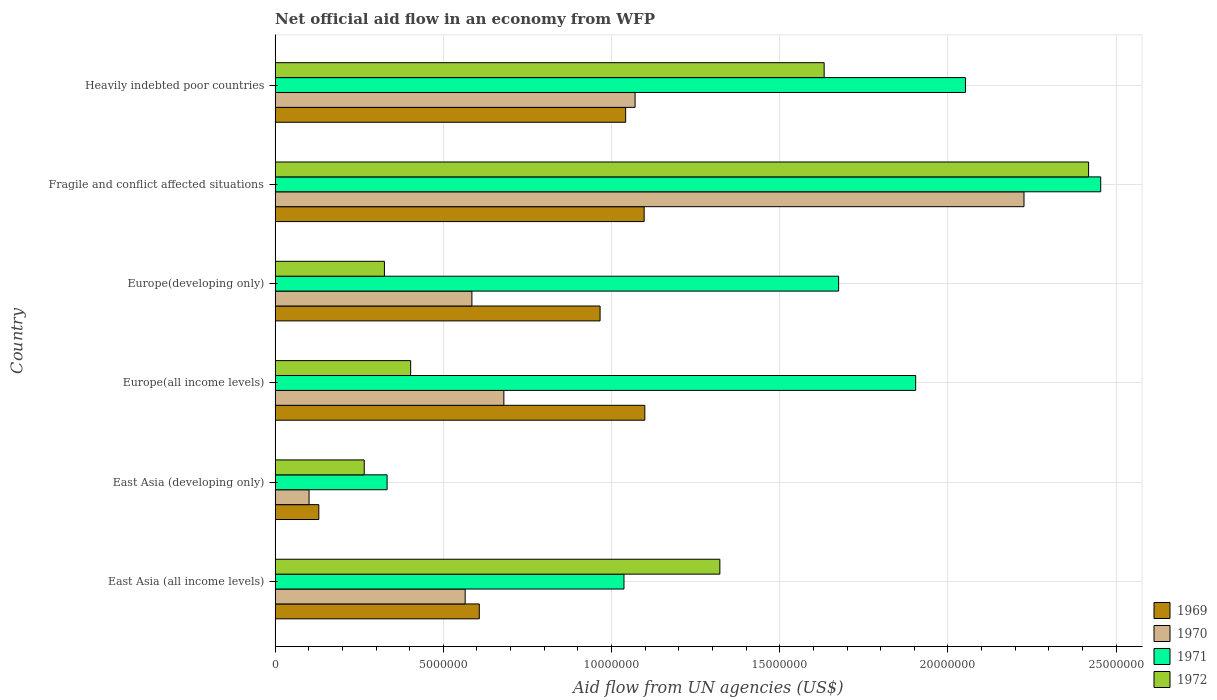Are the number of bars per tick equal to the number of legend labels?
Give a very brief answer. Yes. What is the label of the 5th group of bars from the top?
Your answer should be very brief. East Asia (developing only). In how many cases, is the number of bars for a given country not equal to the number of legend labels?
Offer a terse response. 0. What is the net official aid flow in 1970 in Europe(developing only)?
Ensure brevity in your answer.  5.85e+06. Across all countries, what is the maximum net official aid flow in 1972?
Offer a terse response. 2.42e+07. Across all countries, what is the minimum net official aid flow in 1970?
Ensure brevity in your answer.  1.01e+06. In which country was the net official aid flow in 1969 maximum?
Keep it short and to the point. Europe(all income levels). In which country was the net official aid flow in 1971 minimum?
Make the answer very short. East Asia (developing only). What is the total net official aid flow in 1969 in the graph?
Your answer should be very brief. 4.94e+07. What is the difference between the net official aid flow in 1970 in East Asia (all income levels) and that in East Asia (developing only)?
Provide a succinct answer. 4.64e+06. What is the difference between the net official aid flow in 1970 in East Asia (developing only) and the net official aid flow in 1969 in East Asia (all income levels)?
Provide a succinct answer. -5.06e+06. What is the average net official aid flow in 1969 per country?
Keep it short and to the point. 8.24e+06. What is the difference between the net official aid flow in 1971 and net official aid flow in 1970 in Europe(all income levels)?
Your answer should be very brief. 1.22e+07. What is the ratio of the net official aid flow in 1970 in East Asia (all income levels) to that in East Asia (developing only)?
Keep it short and to the point. 5.59. Is the net official aid flow in 1970 in Europe(all income levels) less than that in Europe(developing only)?
Provide a short and direct response. No. Is the difference between the net official aid flow in 1971 in East Asia (all income levels) and Heavily indebted poor countries greater than the difference between the net official aid flow in 1970 in East Asia (all income levels) and Heavily indebted poor countries?
Offer a terse response. No. What is the difference between the highest and the second highest net official aid flow in 1971?
Keep it short and to the point. 4.02e+06. What is the difference between the highest and the lowest net official aid flow in 1970?
Make the answer very short. 2.12e+07. What does the 1st bar from the top in Heavily indebted poor countries represents?
Make the answer very short. 1972. Is it the case that in every country, the sum of the net official aid flow in 1972 and net official aid flow in 1971 is greater than the net official aid flow in 1970?
Offer a very short reply. Yes. Are all the bars in the graph horizontal?
Ensure brevity in your answer.  Yes. What is the difference between two consecutive major ticks on the X-axis?
Keep it short and to the point. 5.00e+06. Are the values on the major ticks of X-axis written in scientific E-notation?
Offer a very short reply. No. Does the graph contain any zero values?
Keep it short and to the point. No. Does the graph contain grids?
Provide a succinct answer. Yes. Where does the legend appear in the graph?
Keep it short and to the point. Bottom right. How many legend labels are there?
Provide a succinct answer. 4. How are the legend labels stacked?
Your answer should be very brief. Vertical. What is the title of the graph?
Your answer should be compact. Net official aid flow in an economy from WFP. What is the label or title of the X-axis?
Keep it short and to the point. Aid flow from UN agencies (US$). What is the Aid flow from UN agencies (US$) in 1969 in East Asia (all income levels)?
Offer a terse response. 6.07e+06. What is the Aid flow from UN agencies (US$) in 1970 in East Asia (all income levels)?
Offer a very short reply. 5.65e+06. What is the Aid flow from UN agencies (US$) in 1971 in East Asia (all income levels)?
Offer a terse response. 1.04e+07. What is the Aid flow from UN agencies (US$) in 1972 in East Asia (all income levels)?
Provide a succinct answer. 1.32e+07. What is the Aid flow from UN agencies (US$) in 1969 in East Asia (developing only)?
Your answer should be very brief. 1.30e+06. What is the Aid flow from UN agencies (US$) in 1970 in East Asia (developing only)?
Offer a terse response. 1.01e+06. What is the Aid flow from UN agencies (US$) in 1971 in East Asia (developing only)?
Offer a very short reply. 3.33e+06. What is the Aid flow from UN agencies (US$) in 1972 in East Asia (developing only)?
Give a very brief answer. 2.65e+06. What is the Aid flow from UN agencies (US$) of 1969 in Europe(all income levels)?
Make the answer very short. 1.10e+07. What is the Aid flow from UN agencies (US$) of 1970 in Europe(all income levels)?
Ensure brevity in your answer.  6.80e+06. What is the Aid flow from UN agencies (US$) in 1971 in Europe(all income levels)?
Keep it short and to the point. 1.90e+07. What is the Aid flow from UN agencies (US$) in 1972 in Europe(all income levels)?
Offer a very short reply. 4.03e+06. What is the Aid flow from UN agencies (US$) in 1969 in Europe(developing only)?
Provide a succinct answer. 9.66e+06. What is the Aid flow from UN agencies (US$) of 1970 in Europe(developing only)?
Offer a very short reply. 5.85e+06. What is the Aid flow from UN agencies (US$) in 1971 in Europe(developing only)?
Ensure brevity in your answer.  1.68e+07. What is the Aid flow from UN agencies (US$) of 1972 in Europe(developing only)?
Provide a short and direct response. 3.25e+06. What is the Aid flow from UN agencies (US$) in 1969 in Fragile and conflict affected situations?
Make the answer very short. 1.10e+07. What is the Aid flow from UN agencies (US$) in 1970 in Fragile and conflict affected situations?
Make the answer very short. 2.23e+07. What is the Aid flow from UN agencies (US$) in 1971 in Fragile and conflict affected situations?
Your answer should be compact. 2.45e+07. What is the Aid flow from UN agencies (US$) in 1972 in Fragile and conflict affected situations?
Provide a succinct answer. 2.42e+07. What is the Aid flow from UN agencies (US$) in 1969 in Heavily indebted poor countries?
Keep it short and to the point. 1.04e+07. What is the Aid flow from UN agencies (US$) in 1970 in Heavily indebted poor countries?
Your response must be concise. 1.07e+07. What is the Aid flow from UN agencies (US$) in 1971 in Heavily indebted poor countries?
Your answer should be very brief. 2.05e+07. What is the Aid flow from UN agencies (US$) in 1972 in Heavily indebted poor countries?
Your response must be concise. 1.63e+07. Across all countries, what is the maximum Aid flow from UN agencies (US$) of 1969?
Your answer should be very brief. 1.10e+07. Across all countries, what is the maximum Aid flow from UN agencies (US$) in 1970?
Your answer should be very brief. 2.23e+07. Across all countries, what is the maximum Aid flow from UN agencies (US$) of 1971?
Provide a short and direct response. 2.45e+07. Across all countries, what is the maximum Aid flow from UN agencies (US$) in 1972?
Your response must be concise. 2.42e+07. Across all countries, what is the minimum Aid flow from UN agencies (US$) of 1969?
Provide a short and direct response. 1.30e+06. Across all countries, what is the minimum Aid flow from UN agencies (US$) of 1970?
Give a very brief answer. 1.01e+06. Across all countries, what is the minimum Aid flow from UN agencies (US$) in 1971?
Ensure brevity in your answer.  3.33e+06. Across all countries, what is the minimum Aid flow from UN agencies (US$) of 1972?
Your response must be concise. 2.65e+06. What is the total Aid flow from UN agencies (US$) of 1969 in the graph?
Offer a terse response. 4.94e+07. What is the total Aid flow from UN agencies (US$) of 1970 in the graph?
Give a very brief answer. 5.23e+07. What is the total Aid flow from UN agencies (US$) of 1971 in the graph?
Your response must be concise. 9.46e+07. What is the total Aid flow from UN agencies (US$) of 1972 in the graph?
Keep it short and to the point. 6.36e+07. What is the difference between the Aid flow from UN agencies (US$) of 1969 in East Asia (all income levels) and that in East Asia (developing only)?
Your answer should be compact. 4.77e+06. What is the difference between the Aid flow from UN agencies (US$) in 1970 in East Asia (all income levels) and that in East Asia (developing only)?
Give a very brief answer. 4.64e+06. What is the difference between the Aid flow from UN agencies (US$) of 1971 in East Asia (all income levels) and that in East Asia (developing only)?
Keep it short and to the point. 7.04e+06. What is the difference between the Aid flow from UN agencies (US$) of 1972 in East Asia (all income levels) and that in East Asia (developing only)?
Your answer should be very brief. 1.06e+07. What is the difference between the Aid flow from UN agencies (US$) of 1969 in East Asia (all income levels) and that in Europe(all income levels)?
Offer a terse response. -4.92e+06. What is the difference between the Aid flow from UN agencies (US$) of 1970 in East Asia (all income levels) and that in Europe(all income levels)?
Your answer should be very brief. -1.15e+06. What is the difference between the Aid flow from UN agencies (US$) of 1971 in East Asia (all income levels) and that in Europe(all income levels)?
Give a very brief answer. -8.67e+06. What is the difference between the Aid flow from UN agencies (US$) of 1972 in East Asia (all income levels) and that in Europe(all income levels)?
Your answer should be very brief. 9.19e+06. What is the difference between the Aid flow from UN agencies (US$) of 1969 in East Asia (all income levels) and that in Europe(developing only)?
Offer a very short reply. -3.59e+06. What is the difference between the Aid flow from UN agencies (US$) in 1970 in East Asia (all income levels) and that in Europe(developing only)?
Ensure brevity in your answer.  -2.00e+05. What is the difference between the Aid flow from UN agencies (US$) in 1971 in East Asia (all income levels) and that in Europe(developing only)?
Give a very brief answer. -6.38e+06. What is the difference between the Aid flow from UN agencies (US$) of 1972 in East Asia (all income levels) and that in Europe(developing only)?
Offer a terse response. 9.97e+06. What is the difference between the Aid flow from UN agencies (US$) in 1969 in East Asia (all income levels) and that in Fragile and conflict affected situations?
Offer a terse response. -4.90e+06. What is the difference between the Aid flow from UN agencies (US$) of 1970 in East Asia (all income levels) and that in Fragile and conflict affected situations?
Your answer should be very brief. -1.66e+07. What is the difference between the Aid flow from UN agencies (US$) of 1971 in East Asia (all income levels) and that in Fragile and conflict affected situations?
Make the answer very short. -1.42e+07. What is the difference between the Aid flow from UN agencies (US$) of 1972 in East Asia (all income levels) and that in Fragile and conflict affected situations?
Keep it short and to the point. -1.10e+07. What is the difference between the Aid flow from UN agencies (US$) in 1969 in East Asia (all income levels) and that in Heavily indebted poor countries?
Offer a very short reply. -4.35e+06. What is the difference between the Aid flow from UN agencies (US$) of 1970 in East Asia (all income levels) and that in Heavily indebted poor countries?
Make the answer very short. -5.05e+06. What is the difference between the Aid flow from UN agencies (US$) of 1971 in East Asia (all income levels) and that in Heavily indebted poor countries?
Keep it short and to the point. -1.02e+07. What is the difference between the Aid flow from UN agencies (US$) of 1972 in East Asia (all income levels) and that in Heavily indebted poor countries?
Offer a terse response. -3.10e+06. What is the difference between the Aid flow from UN agencies (US$) in 1969 in East Asia (developing only) and that in Europe(all income levels)?
Make the answer very short. -9.69e+06. What is the difference between the Aid flow from UN agencies (US$) in 1970 in East Asia (developing only) and that in Europe(all income levels)?
Offer a terse response. -5.79e+06. What is the difference between the Aid flow from UN agencies (US$) of 1971 in East Asia (developing only) and that in Europe(all income levels)?
Provide a succinct answer. -1.57e+07. What is the difference between the Aid flow from UN agencies (US$) of 1972 in East Asia (developing only) and that in Europe(all income levels)?
Your answer should be compact. -1.38e+06. What is the difference between the Aid flow from UN agencies (US$) in 1969 in East Asia (developing only) and that in Europe(developing only)?
Your answer should be very brief. -8.36e+06. What is the difference between the Aid flow from UN agencies (US$) of 1970 in East Asia (developing only) and that in Europe(developing only)?
Provide a short and direct response. -4.84e+06. What is the difference between the Aid flow from UN agencies (US$) of 1971 in East Asia (developing only) and that in Europe(developing only)?
Offer a very short reply. -1.34e+07. What is the difference between the Aid flow from UN agencies (US$) in 1972 in East Asia (developing only) and that in Europe(developing only)?
Keep it short and to the point. -6.00e+05. What is the difference between the Aid flow from UN agencies (US$) of 1969 in East Asia (developing only) and that in Fragile and conflict affected situations?
Your answer should be very brief. -9.67e+06. What is the difference between the Aid flow from UN agencies (US$) of 1970 in East Asia (developing only) and that in Fragile and conflict affected situations?
Give a very brief answer. -2.12e+07. What is the difference between the Aid flow from UN agencies (US$) of 1971 in East Asia (developing only) and that in Fragile and conflict affected situations?
Ensure brevity in your answer.  -2.12e+07. What is the difference between the Aid flow from UN agencies (US$) of 1972 in East Asia (developing only) and that in Fragile and conflict affected situations?
Keep it short and to the point. -2.15e+07. What is the difference between the Aid flow from UN agencies (US$) in 1969 in East Asia (developing only) and that in Heavily indebted poor countries?
Your answer should be very brief. -9.12e+06. What is the difference between the Aid flow from UN agencies (US$) of 1970 in East Asia (developing only) and that in Heavily indebted poor countries?
Ensure brevity in your answer.  -9.69e+06. What is the difference between the Aid flow from UN agencies (US$) of 1971 in East Asia (developing only) and that in Heavily indebted poor countries?
Offer a very short reply. -1.72e+07. What is the difference between the Aid flow from UN agencies (US$) of 1972 in East Asia (developing only) and that in Heavily indebted poor countries?
Your response must be concise. -1.37e+07. What is the difference between the Aid flow from UN agencies (US$) of 1969 in Europe(all income levels) and that in Europe(developing only)?
Offer a very short reply. 1.33e+06. What is the difference between the Aid flow from UN agencies (US$) in 1970 in Europe(all income levels) and that in Europe(developing only)?
Provide a succinct answer. 9.50e+05. What is the difference between the Aid flow from UN agencies (US$) of 1971 in Europe(all income levels) and that in Europe(developing only)?
Your response must be concise. 2.29e+06. What is the difference between the Aid flow from UN agencies (US$) of 1972 in Europe(all income levels) and that in Europe(developing only)?
Make the answer very short. 7.80e+05. What is the difference between the Aid flow from UN agencies (US$) of 1969 in Europe(all income levels) and that in Fragile and conflict affected situations?
Keep it short and to the point. 2.00e+04. What is the difference between the Aid flow from UN agencies (US$) of 1970 in Europe(all income levels) and that in Fragile and conflict affected situations?
Ensure brevity in your answer.  -1.55e+07. What is the difference between the Aid flow from UN agencies (US$) of 1971 in Europe(all income levels) and that in Fragile and conflict affected situations?
Give a very brief answer. -5.50e+06. What is the difference between the Aid flow from UN agencies (US$) of 1972 in Europe(all income levels) and that in Fragile and conflict affected situations?
Your answer should be compact. -2.02e+07. What is the difference between the Aid flow from UN agencies (US$) in 1969 in Europe(all income levels) and that in Heavily indebted poor countries?
Offer a terse response. 5.70e+05. What is the difference between the Aid flow from UN agencies (US$) of 1970 in Europe(all income levels) and that in Heavily indebted poor countries?
Give a very brief answer. -3.90e+06. What is the difference between the Aid flow from UN agencies (US$) of 1971 in Europe(all income levels) and that in Heavily indebted poor countries?
Keep it short and to the point. -1.48e+06. What is the difference between the Aid flow from UN agencies (US$) of 1972 in Europe(all income levels) and that in Heavily indebted poor countries?
Offer a terse response. -1.23e+07. What is the difference between the Aid flow from UN agencies (US$) in 1969 in Europe(developing only) and that in Fragile and conflict affected situations?
Offer a very short reply. -1.31e+06. What is the difference between the Aid flow from UN agencies (US$) in 1970 in Europe(developing only) and that in Fragile and conflict affected situations?
Give a very brief answer. -1.64e+07. What is the difference between the Aid flow from UN agencies (US$) of 1971 in Europe(developing only) and that in Fragile and conflict affected situations?
Your answer should be compact. -7.79e+06. What is the difference between the Aid flow from UN agencies (US$) in 1972 in Europe(developing only) and that in Fragile and conflict affected situations?
Your answer should be very brief. -2.09e+07. What is the difference between the Aid flow from UN agencies (US$) of 1969 in Europe(developing only) and that in Heavily indebted poor countries?
Offer a terse response. -7.60e+05. What is the difference between the Aid flow from UN agencies (US$) in 1970 in Europe(developing only) and that in Heavily indebted poor countries?
Provide a succinct answer. -4.85e+06. What is the difference between the Aid flow from UN agencies (US$) in 1971 in Europe(developing only) and that in Heavily indebted poor countries?
Offer a terse response. -3.77e+06. What is the difference between the Aid flow from UN agencies (US$) of 1972 in Europe(developing only) and that in Heavily indebted poor countries?
Give a very brief answer. -1.31e+07. What is the difference between the Aid flow from UN agencies (US$) of 1970 in Fragile and conflict affected situations and that in Heavily indebted poor countries?
Keep it short and to the point. 1.16e+07. What is the difference between the Aid flow from UN agencies (US$) of 1971 in Fragile and conflict affected situations and that in Heavily indebted poor countries?
Give a very brief answer. 4.02e+06. What is the difference between the Aid flow from UN agencies (US$) of 1972 in Fragile and conflict affected situations and that in Heavily indebted poor countries?
Make the answer very short. 7.86e+06. What is the difference between the Aid flow from UN agencies (US$) in 1969 in East Asia (all income levels) and the Aid flow from UN agencies (US$) in 1970 in East Asia (developing only)?
Give a very brief answer. 5.06e+06. What is the difference between the Aid flow from UN agencies (US$) of 1969 in East Asia (all income levels) and the Aid flow from UN agencies (US$) of 1971 in East Asia (developing only)?
Your response must be concise. 2.74e+06. What is the difference between the Aid flow from UN agencies (US$) of 1969 in East Asia (all income levels) and the Aid flow from UN agencies (US$) of 1972 in East Asia (developing only)?
Provide a short and direct response. 3.42e+06. What is the difference between the Aid flow from UN agencies (US$) of 1970 in East Asia (all income levels) and the Aid flow from UN agencies (US$) of 1971 in East Asia (developing only)?
Provide a short and direct response. 2.32e+06. What is the difference between the Aid flow from UN agencies (US$) of 1970 in East Asia (all income levels) and the Aid flow from UN agencies (US$) of 1972 in East Asia (developing only)?
Keep it short and to the point. 3.00e+06. What is the difference between the Aid flow from UN agencies (US$) of 1971 in East Asia (all income levels) and the Aid flow from UN agencies (US$) of 1972 in East Asia (developing only)?
Your response must be concise. 7.72e+06. What is the difference between the Aid flow from UN agencies (US$) of 1969 in East Asia (all income levels) and the Aid flow from UN agencies (US$) of 1970 in Europe(all income levels)?
Give a very brief answer. -7.30e+05. What is the difference between the Aid flow from UN agencies (US$) of 1969 in East Asia (all income levels) and the Aid flow from UN agencies (US$) of 1971 in Europe(all income levels)?
Your response must be concise. -1.30e+07. What is the difference between the Aid flow from UN agencies (US$) of 1969 in East Asia (all income levels) and the Aid flow from UN agencies (US$) of 1972 in Europe(all income levels)?
Your response must be concise. 2.04e+06. What is the difference between the Aid flow from UN agencies (US$) of 1970 in East Asia (all income levels) and the Aid flow from UN agencies (US$) of 1971 in Europe(all income levels)?
Your answer should be compact. -1.34e+07. What is the difference between the Aid flow from UN agencies (US$) of 1970 in East Asia (all income levels) and the Aid flow from UN agencies (US$) of 1972 in Europe(all income levels)?
Give a very brief answer. 1.62e+06. What is the difference between the Aid flow from UN agencies (US$) of 1971 in East Asia (all income levels) and the Aid flow from UN agencies (US$) of 1972 in Europe(all income levels)?
Provide a succinct answer. 6.34e+06. What is the difference between the Aid flow from UN agencies (US$) in 1969 in East Asia (all income levels) and the Aid flow from UN agencies (US$) in 1971 in Europe(developing only)?
Provide a succinct answer. -1.07e+07. What is the difference between the Aid flow from UN agencies (US$) in 1969 in East Asia (all income levels) and the Aid flow from UN agencies (US$) in 1972 in Europe(developing only)?
Offer a terse response. 2.82e+06. What is the difference between the Aid flow from UN agencies (US$) of 1970 in East Asia (all income levels) and the Aid flow from UN agencies (US$) of 1971 in Europe(developing only)?
Make the answer very short. -1.11e+07. What is the difference between the Aid flow from UN agencies (US$) in 1970 in East Asia (all income levels) and the Aid flow from UN agencies (US$) in 1972 in Europe(developing only)?
Ensure brevity in your answer.  2.40e+06. What is the difference between the Aid flow from UN agencies (US$) of 1971 in East Asia (all income levels) and the Aid flow from UN agencies (US$) of 1972 in Europe(developing only)?
Your response must be concise. 7.12e+06. What is the difference between the Aid flow from UN agencies (US$) in 1969 in East Asia (all income levels) and the Aid flow from UN agencies (US$) in 1970 in Fragile and conflict affected situations?
Offer a very short reply. -1.62e+07. What is the difference between the Aid flow from UN agencies (US$) in 1969 in East Asia (all income levels) and the Aid flow from UN agencies (US$) in 1971 in Fragile and conflict affected situations?
Offer a very short reply. -1.85e+07. What is the difference between the Aid flow from UN agencies (US$) in 1969 in East Asia (all income levels) and the Aid flow from UN agencies (US$) in 1972 in Fragile and conflict affected situations?
Make the answer very short. -1.81e+07. What is the difference between the Aid flow from UN agencies (US$) of 1970 in East Asia (all income levels) and the Aid flow from UN agencies (US$) of 1971 in Fragile and conflict affected situations?
Give a very brief answer. -1.89e+07. What is the difference between the Aid flow from UN agencies (US$) of 1970 in East Asia (all income levels) and the Aid flow from UN agencies (US$) of 1972 in Fragile and conflict affected situations?
Your answer should be very brief. -1.85e+07. What is the difference between the Aid flow from UN agencies (US$) in 1971 in East Asia (all income levels) and the Aid flow from UN agencies (US$) in 1972 in Fragile and conflict affected situations?
Provide a short and direct response. -1.38e+07. What is the difference between the Aid flow from UN agencies (US$) of 1969 in East Asia (all income levels) and the Aid flow from UN agencies (US$) of 1970 in Heavily indebted poor countries?
Give a very brief answer. -4.63e+06. What is the difference between the Aid flow from UN agencies (US$) of 1969 in East Asia (all income levels) and the Aid flow from UN agencies (US$) of 1971 in Heavily indebted poor countries?
Provide a short and direct response. -1.44e+07. What is the difference between the Aid flow from UN agencies (US$) in 1969 in East Asia (all income levels) and the Aid flow from UN agencies (US$) in 1972 in Heavily indebted poor countries?
Ensure brevity in your answer.  -1.02e+07. What is the difference between the Aid flow from UN agencies (US$) in 1970 in East Asia (all income levels) and the Aid flow from UN agencies (US$) in 1971 in Heavily indebted poor countries?
Keep it short and to the point. -1.49e+07. What is the difference between the Aid flow from UN agencies (US$) in 1970 in East Asia (all income levels) and the Aid flow from UN agencies (US$) in 1972 in Heavily indebted poor countries?
Your answer should be compact. -1.07e+07. What is the difference between the Aid flow from UN agencies (US$) in 1971 in East Asia (all income levels) and the Aid flow from UN agencies (US$) in 1972 in Heavily indebted poor countries?
Give a very brief answer. -5.95e+06. What is the difference between the Aid flow from UN agencies (US$) in 1969 in East Asia (developing only) and the Aid flow from UN agencies (US$) in 1970 in Europe(all income levels)?
Offer a very short reply. -5.50e+06. What is the difference between the Aid flow from UN agencies (US$) in 1969 in East Asia (developing only) and the Aid flow from UN agencies (US$) in 1971 in Europe(all income levels)?
Offer a terse response. -1.77e+07. What is the difference between the Aid flow from UN agencies (US$) in 1969 in East Asia (developing only) and the Aid flow from UN agencies (US$) in 1972 in Europe(all income levels)?
Make the answer very short. -2.73e+06. What is the difference between the Aid flow from UN agencies (US$) of 1970 in East Asia (developing only) and the Aid flow from UN agencies (US$) of 1971 in Europe(all income levels)?
Your answer should be compact. -1.80e+07. What is the difference between the Aid flow from UN agencies (US$) of 1970 in East Asia (developing only) and the Aid flow from UN agencies (US$) of 1972 in Europe(all income levels)?
Ensure brevity in your answer.  -3.02e+06. What is the difference between the Aid flow from UN agencies (US$) of 1971 in East Asia (developing only) and the Aid flow from UN agencies (US$) of 1972 in Europe(all income levels)?
Ensure brevity in your answer.  -7.00e+05. What is the difference between the Aid flow from UN agencies (US$) of 1969 in East Asia (developing only) and the Aid flow from UN agencies (US$) of 1970 in Europe(developing only)?
Your answer should be very brief. -4.55e+06. What is the difference between the Aid flow from UN agencies (US$) in 1969 in East Asia (developing only) and the Aid flow from UN agencies (US$) in 1971 in Europe(developing only)?
Provide a short and direct response. -1.54e+07. What is the difference between the Aid flow from UN agencies (US$) in 1969 in East Asia (developing only) and the Aid flow from UN agencies (US$) in 1972 in Europe(developing only)?
Provide a short and direct response. -1.95e+06. What is the difference between the Aid flow from UN agencies (US$) in 1970 in East Asia (developing only) and the Aid flow from UN agencies (US$) in 1971 in Europe(developing only)?
Give a very brief answer. -1.57e+07. What is the difference between the Aid flow from UN agencies (US$) in 1970 in East Asia (developing only) and the Aid flow from UN agencies (US$) in 1972 in Europe(developing only)?
Ensure brevity in your answer.  -2.24e+06. What is the difference between the Aid flow from UN agencies (US$) of 1971 in East Asia (developing only) and the Aid flow from UN agencies (US$) of 1972 in Europe(developing only)?
Give a very brief answer. 8.00e+04. What is the difference between the Aid flow from UN agencies (US$) of 1969 in East Asia (developing only) and the Aid flow from UN agencies (US$) of 1970 in Fragile and conflict affected situations?
Provide a short and direct response. -2.10e+07. What is the difference between the Aid flow from UN agencies (US$) of 1969 in East Asia (developing only) and the Aid flow from UN agencies (US$) of 1971 in Fragile and conflict affected situations?
Your answer should be compact. -2.32e+07. What is the difference between the Aid flow from UN agencies (US$) in 1969 in East Asia (developing only) and the Aid flow from UN agencies (US$) in 1972 in Fragile and conflict affected situations?
Provide a short and direct response. -2.29e+07. What is the difference between the Aid flow from UN agencies (US$) in 1970 in East Asia (developing only) and the Aid flow from UN agencies (US$) in 1971 in Fragile and conflict affected situations?
Provide a short and direct response. -2.35e+07. What is the difference between the Aid flow from UN agencies (US$) of 1970 in East Asia (developing only) and the Aid flow from UN agencies (US$) of 1972 in Fragile and conflict affected situations?
Offer a terse response. -2.32e+07. What is the difference between the Aid flow from UN agencies (US$) in 1971 in East Asia (developing only) and the Aid flow from UN agencies (US$) in 1972 in Fragile and conflict affected situations?
Your response must be concise. -2.08e+07. What is the difference between the Aid flow from UN agencies (US$) in 1969 in East Asia (developing only) and the Aid flow from UN agencies (US$) in 1970 in Heavily indebted poor countries?
Provide a succinct answer. -9.40e+06. What is the difference between the Aid flow from UN agencies (US$) in 1969 in East Asia (developing only) and the Aid flow from UN agencies (US$) in 1971 in Heavily indebted poor countries?
Your answer should be very brief. -1.92e+07. What is the difference between the Aid flow from UN agencies (US$) of 1969 in East Asia (developing only) and the Aid flow from UN agencies (US$) of 1972 in Heavily indebted poor countries?
Provide a short and direct response. -1.50e+07. What is the difference between the Aid flow from UN agencies (US$) in 1970 in East Asia (developing only) and the Aid flow from UN agencies (US$) in 1971 in Heavily indebted poor countries?
Make the answer very short. -1.95e+07. What is the difference between the Aid flow from UN agencies (US$) in 1970 in East Asia (developing only) and the Aid flow from UN agencies (US$) in 1972 in Heavily indebted poor countries?
Your answer should be very brief. -1.53e+07. What is the difference between the Aid flow from UN agencies (US$) in 1971 in East Asia (developing only) and the Aid flow from UN agencies (US$) in 1972 in Heavily indebted poor countries?
Keep it short and to the point. -1.30e+07. What is the difference between the Aid flow from UN agencies (US$) in 1969 in Europe(all income levels) and the Aid flow from UN agencies (US$) in 1970 in Europe(developing only)?
Ensure brevity in your answer.  5.14e+06. What is the difference between the Aid flow from UN agencies (US$) in 1969 in Europe(all income levels) and the Aid flow from UN agencies (US$) in 1971 in Europe(developing only)?
Provide a short and direct response. -5.76e+06. What is the difference between the Aid flow from UN agencies (US$) of 1969 in Europe(all income levels) and the Aid flow from UN agencies (US$) of 1972 in Europe(developing only)?
Offer a very short reply. 7.74e+06. What is the difference between the Aid flow from UN agencies (US$) of 1970 in Europe(all income levels) and the Aid flow from UN agencies (US$) of 1971 in Europe(developing only)?
Make the answer very short. -9.95e+06. What is the difference between the Aid flow from UN agencies (US$) in 1970 in Europe(all income levels) and the Aid flow from UN agencies (US$) in 1972 in Europe(developing only)?
Give a very brief answer. 3.55e+06. What is the difference between the Aid flow from UN agencies (US$) of 1971 in Europe(all income levels) and the Aid flow from UN agencies (US$) of 1972 in Europe(developing only)?
Offer a terse response. 1.58e+07. What is the difference between the Aid flow from UN agencies (US$) of 1969 in Europe(all income levels) and the Aid flow from UN agencies (US$) of 1970 in Fragile and conflict affected situations?
Offer a very short reply. -1.13e+07. What is the difference between the Aid flow from UN agencies (US$) of 1969 in Europe(all income levels) and the Aid flow from UN agencies (US$) of 1971 in Fragile and conflict affected situations?
Offer a terse response. -1.36e+07. What is the difference between the Aid flow from UN agencies (US$) of 1969 in Europe(all income levels) and the Aid flow from UN agencies (US$) of 1972 in Fragile and conflict affected situations?
Give a very brief answer. -1.32e+07. What is the difference between the Aid flow from UN agencies (US$) of 1970 in Europe(all income levels) and the Aid flow from UN agencies (US$) of 1971 in Fragile and conflict affected situations?
Ensure brevity in your answer.  -1.77e+07. What is the difference between the Aid flow from UN agencies (US$) of 1970 in Europe(all income levels) and the Aid flow from UN agencies (US$) of 1972 in Fragile and conflict affected situations?
Offer a very short reply. -1.74e+07. What is the difference between the Aid flow from UN agencies (US$) in 1971 in Europe(all income levels) and the Aid flow from UN agencies (US$) in 1972 in Fragile and conflict affected situations?
Make the answer very short. -5.14e+06. What is the difference between the Aid flow from UN agencies (US$) of 1969 in Europe(all income levels) and the Aid flow from UN agencies (US$) of 1970 in Heavily indebted poor countries?
Make the answer very short. 2.90e+05. What is the difference between the Aid flow from UN agencies (US$) of 1969 in Europe(all income levels) and the Aid flow from UN agencies (US$) of 1971 in Heavily indebted poor countries?
Provide a succinct answer. -9.53e+06. What is the difference between the Aid flow from UN agencies (US$) of 1969 in Europe(all income levels) and the Aid flow from UN agencies (US$) of 1972 in Heavily indebted poor countries?
Ensure brevity in your answer.  -5.33e+06. What is the difference between the Aid flow from UN agencies (US$) in 1970 in Europe(all income levels) and the Aid flow from UN agencies (US$) in 1971 in Heavily indebted poor countries?
Your answer should be compact. -1.37e+07. What is the difference between the Aid flow from UN agencies (US$) of 1970 in Europe(all income levels) and the Aid flow from UN agencies (US$) of 1972 in Heavily indebted poor countries?
Keep it short and to the point. -9.52e+06. What is the difference between the Aid flow from UN agencies (US$) in 1971 in Europe(all income levels) and the Aid flow from UN agencies (US$) in 1972 in Heavily indebted poor countries?
Ensure brevity in your answer.  2.72e+06. What is the difference between the Aid flow from UN agencies (US$) of 1969 in Europe(developing only) and the Aid flow from UN agencies (US$) of 1970 in Fragile and conflict affected situations?
Offer a terse response. -1.26e+07. What is the difference between the Aid flow from UN agencies (US$) in 1969 in Europe(developing only) and the Aid flow from UN agencies (US$) in 1971 in Fragile and conflict affected situations?
Keep it short and to the point. -1.49e+07. What is the difference between the Aid flow from UN agencies (US$) in 1969 in Europe(developing only) and the Aid flow from UN agencies (US$) in 1972 in Fragile and conflict affected situations?
Ensure brevity in your answer.  -1.45e+07. What is the difference between the Aid flow from UN agencies (US$) in 1970 in Europe(developing only) and the Aid flow from UN agencies (US$) in 1971 in Fragile and conflict affected situations?
Keep it short and to the point. -1.87e+07. What is the difference between the Aid flow from UN agencies (US$) of 1970 in Europe(developing only) and the Aid flow from UN agencies (US$) of 1972 in Fragile and conflict affected situations?
Ensure brevity in your answer.  -1.83e+07. What is the difference between the Aid flow from UN agencies (US$) in 1971 in Europe(developing only) and the Aid flow from UN agencies (US$) in 1972 in Fragile and conflict affected situations?
Offer a very short reply. -7.43e+06. What is the difference between the Aid flow from UN agencies (US$) in 1969 in Europe(developing only) and the Aid flow from UN agencies (US$) in 1970 in Heavily indebted poor countries?
Your response must be concise. -1.04e+06. What is the difference between the Aid flow from UN agencies (US$) in 1969 in Europe(developing only) and the Aid flow from UN agencies (US$) in 1971 in Heavily indebted poor countries?
Your answer should be very brief. -1.09e+07. What is the difference between the Aid flow from UN agencies (US$) of 1969 in Europe(developing only) and the Aid flow from UN agencies (US$) of 1972 in Heavily indebted poor countries?
Offer a terse response. -6.66e+06. What is the difference between the Aid flow from UN agencies (US$) in 1970 in Europe(developing only) and the Aid flow from UN agencies (US$) in 1971 in Heavily indebted poor countries?
Provide a short and direct response. -1.47e+07. What is the difference between the Aid flow from UN agencies (US$) in 1970 in Europe(developing only) and the Aid flow from UN agencies (US$) in 1972 in Heavily indebted poor countries?
Provide a succinct answer. -1.05e+07. What is the difference between the Aid flow from UN agencies (US$) of 1971 in Europe(developing only) and the Aid flow from UN agencies (US$) of 1972 in Heavily indebted poor countries?
Ensure brevity in your answer.  4.30e+05. What is the difference between the Aid flow from UN agencies (US$) in 1969 in Fragile and conflict affected situations and the Aid flow from UN agencies (US$) in 1970 in Heavily indebted poor countries?
Your answer should be compact. 2.70e+05. What is the difference between the Aid flow from UN agencies (US$) of 1969 in Fragile and conflict affected situations and the Aid flow from UN agencies (US$) of 1971 in Heavily indebted poor countries?
Your answer should be very brief. -9.55e+06. What is the difference between the Aid flow from UN agencies (US$) of 1969 in Fragile and conflict affected situations and the Aid flow from UN agencies (US$) of 1972 in Heavily indebted poor countries?
Make the answer very short. -5.35e+06. What is the difference between the Aid flow from UN agencies (US$) in 1970 in Fragile and conflict affected situations and the Aid flow from UN agencies (US$) in 1971 in Heavily indebted poor countries?
Provide a succinct answer. 1.74e+06. What is the difference between the Aid flow from UN agencies (US$) in 1970 in Fragile and conflict affected situations and the Aid flow from UN agencies (US$) in 1972 in Heavily indebted poor countries?
Provide a succinct answer. 5.94e+06. What is the difference between the Aid flow from UN agencies (US$) of 1971 in Fragile and conflict affected situations and the Aid flow from UN agencies (US$) of 1972 in Heavily indebted poor countries?
Offer a terse response. 8.22e+06. What is the average Aid flow from UN agencies (US$) of 1969 per country?
Keep it short and to the point. 8.24e+06. What is the average Aid flow from UN agencies (US$) in 1970 per country?
Provide a succinct answer. 8.71e+06. What is the average Aid flow from UN agencies (US$) of 1971 per country?
Make the answer very short. 1.58e+07. What is the average Aid flow from UN agencies (US$) of 1972 per country?
Ensure brevity in your answer.  1.06e+07. What is the difference between the Aid flow from UN agencies (US$) of 1969 and Aid flow from UN agencies (US$) of 1971 in East Asia (all income levels)?
Make the answer very short. -4.30e+06. What is the difference between the Aid flow from UN agencies (US$) in 1969 and Aid flow from UN agencies (US$) in 1972 in East Asia (all income levels)?
Your response must be concise. -7.15e+06. What is the difference between the Aid flow from UN agencies (US$) of 1970 and Aid flow from UN agencies (US$) of 1971 in East Asia (all income levels)?
Your answer should be very brief. -4.72e+06. What is the difference between the Aid flow from UN agencies (US$) of 1970 and Aid flow from UN agencies (US$) of 1972 in East Asia (all income levels)?
Provide a succinct answer. -7.57e+06. What is the difference between the Aid flow from UN agencies (US$) of 1971 and Aid flow from UN agencies (US$) of 1972 in East Asia (all income levels)?
Your answer should be compact. -2.85e+06. What is the difference between the Aid flow from UN agencies (US$) of 1969 and Aid flow from UN agencies (US$) of 1970 in East Asia (developing only)?
Provide a short and direct response. 2.90e+05. What is the difference between the Aid flow from UN agencies (US$) of 1969 and Aid flow from UN agencies (US$) of 1971 in East Asia (developing only)?
Your response must be concise. -2.03e+06. What is the difference between the Aid flow from UN agencies (US$) of 1969 and Aid flow from UN agencies (US$) of 1972 in East Asia (developing only)?
Provide a succinct answer. -1.35e+06. What is the difference between the Aid flow from UN agencies (US$) in 1970 and Aid flow from UN agencies (US$) in 1971 in East Asia (developing only)?
Offer a very short reply. -2.32e+06. What is the difference between the Aid flow from UN agencies (US$) of 1970 and Aid flow from UN agencies (US$) of 1972 in East Asia (developing only)?
Offer a very short reply. -1.64e+06. What is the difference between the Aid flow from UN agencies (US$) in 1971 and Aid flow from UN agencies (US$) in 1972 in East Asia (developing only)?
Make the answer very short. 6.80e+05. What is the difference between the Aid flow from UN agencies (US$) of 1969 and Aid flow from UN agencies (US$) of 1970 in Europe(all income levels)?
Your response must be concise. 4.19e+06. What is the difference between the Aid flow from UN agencies (US$) in 1969 and Aid flow from UN agencies (US$) in 1971 in Europe(all income levels)?
Keep it short and to the point. -8.05e+06. What is the difference between the Aid flow from UN agencies (US$) of 1969 and Aid flow from UN agencies (US$) of 1972 in Europe(all income levels)?
Your answer should be compact. 6.96e+06. What is the difference between the Aid flow from UN agencies (US$) in 1970 and Aid flow from UN agencies (US$) in 1971 in Europe(all income levels)?
Offer a very short reply. -1.22e+07. What is the difference between the Aid flow from UN agencies (US$) in 1970 and Aid flow from UN agencies (US$) in 1972 in Europe(all income levels)?
Provide a succinct answer. 2.77e+06. What is the difference between the Aid flow from UN agencies (US$) of 1971 and Aid flow from UN agencies (US$) of 1972 in Europe(all income levels)?
Provide a succinct answer. 1.50e+07. What is the difference between the Aid flow from UN agencies (US$) in 1969 and Aid flow from UN agencies (US$) in 1970 in Europe(developing only)?
Make the answer very short. 3.81e+06. What is the difference between the Aid flow from UN agencies (US$) in 1969 and Aid flow from UN agencies (US$) in 1971 in Europe(developing only)?
Give a very brief answer. -7.09e+06. What is the difference between the Aid flow from UN agencies (US$) of 1969 and Aid flow from UN agencies (US$) of 1972 in Europe(developing only)?
Provide a short and direct response. 6.41e+06. What is the difference between the Aid flow from UN agencies (US$) of 1970 and Aid flow from UN agencies (US$) of 1971 in Europe(developing only)?
Offer a terse response. -1.09e+07. What is the difference between the Aid flow from UN agencies (US$) of 1970 and Aid flow from UN agencies (US$) of 1972 in Europe(developing only)?
Your response must be concise. 2.60e+06. What is the difference between the Aid flow from UN agencies (US$) in 1971 and Aid flow from UN agencies (US$) in 1972 in Europe(developing only)?
Your answer should be compact. 1.35e+07. What is the difference between the Aid flow from UN agencies (US$) in 1969 and Aid flow from UN agencies (US$) in 1970 in Fragile and conflict affected situations?
Your answer should be very brief. -1.13e+07. What is the difference between the Aid flow from UN agencies (US$) in 1969 and Aid flow from UN agencies (US$) in 1971 in Fragile and conflict affected situations?
Provide a succinct answer. -1.36e+07. What is the difference between the Aid flow from UN agencies (US$) of 1969 and Aid flow from UN agencies (US$) of 1972 in Fragile and conflict affected situations?
Make the answer very short. -1.32e+07. What is the difference between the Aid flow from UN agencies (US$) of 1970 and Aid flow from UN agencies (US$) of 1971 in Fragile and conflict affected situations?
Offer a terse response. -2.28e+06. What is the difference between the Aid flow from UN agencies (US$) of 1970 and Aid flow from UN agencies (US$) of 1972 in Fragile and conflict affected situations?
Provide a short and direct response. -1.92e+06. What is the difference between the Aid flow from UN agencies (US$) in 1971 and Aid flow from UN agencies (US$) in 1972 in Fragile and conflict affected situations?
Offer a very short reply. 3.60e+05. What is the difference between the Aid flow from UN agencies (US$) in 1969 and Aid flow from UN agencies (US$) in 1970 in Heavily indebted poor countries?
Give a very brief answer. -2.80e+05. What is the difference between the Aid flow from UN agencies (US$) in 1969 and Aid flow from UN agencies (US$) in 1971 in Heavily indebted poor countries?
Provide a short and direct response. -1.01e+07. What is the difference between the Aid flow from UN agencies (US$) in 1969 and Aid flow from UN agencies (US$) in 1972 in Heavily indebted poor countries?
Offer a very short reply. -5.90e+06. What is the difference between the Aid flow from UN agencies (US$) in 1970 and Aid flow from UN agencies (US$) in 1971 in Heavily indebted poor countries?
Provide a short and direct response. -9.82e+06. What is the difference between the Aid flow from UN agencies (US$) of 1970 and Aid flow from UN agencies (US$) of 1972 in Heavily indebted poor countries?
Offer a terse response. -5.62e+06. What is the difference between the Aid flow from UN agencies (US$) in 1971 and Aid flow from UN agencies (US$) in 1972 in Heavily indebted poor countries?
Your answer should be very brief. 4.20e+06. What is the ratio of the Aid flow from UN agencies (US$) in 1969 in East Asia (all income levels) to that in East Asia (developing only)?
Offer a very short reply. 4.67. What is the ratio of the Aid flow from UN agencies (US$) in 1970 in East Asia (all income levels) to that in East Asia (developing only)?
Your response must be concise. 5.59. What is the ratio of the Aid flow from UN agencies (US$) of 1971 in East Asia (all income levels) to that in East Asia (developing only)?
Provide a short and direct response. 3.11. What is the ratio of the Aid flow from UN agencies (US$) of 1972 in East Asia (all income levels) to that in East Asia (developing only)?
Offer a terse response. 4.99. What is the ratio of the Aid flow from UN agencies (US$) of 1969 in East Asia (all income levels) to that in Europe(all income levels)?
Your answer should be very brief. 0.55. What is the ratio of the Aid flow from UN agencies (US$) in 1970 in East Asia (all income levels) to that in Europe(all income levels)?
Your answer should be compact. 0.83. What is the ratio of the Aid flow from UN agencies (US$) in 1971 in East Asia (all income levels) to that in Europe(all income levels)?
Offer a very short reply. 0.54. What is the ratio of the Aid flow from UN agencies (US$) in 1972 in East Asia (all income levels) to that in Europe(all income levels)?
Provide a short and direct response. 3.28. What is the ratio of the Aid flow from UN agencies (US$) of 1969 in East Asia (all income levels) to that in Europe(developing only)?
Keep it short and to the point. 0.63. What is the ratio of the Aid flow from UN agencies (US$) of 1970 in East Asia (all income levels) to that in Europe(developing only)?
Make the answer very short. 0.97. What is the ratio of the Aid flow from UN agencies (US$) in 1971 in East Asia (all income levels) to that in Europe(developing only)?
Provide a succinct answer. 0.62. What is the ratio of the Aid flow from UN agencies (US$) in 1972 in East Asia (all income levels) to that in Europe(developing only)?
Provide a succinct answer. 4.07. What is the ratio of the Aid flow from UN agencies (US$) in 1969 in East Asia (all income levels) to that in Fragile and conflict affected situations?
Give a very brief answer. 0.55. What is the ratio of the Aid flow from UN agencies (US$) in 1970 in East Asia (all income levels) to that in Fragile and conflict affected situations?
Make the answer very short. 0.25. What is the ratio of the Aid flow from UN agencies (US$) in 1971 in East Asia (all income levels) to that in Fragile and conflict affected situations?
Provide a succinct answer. 0.42. What is the ratio of the Aid flow from UN agencies (US$) in 1972 in East Asia (all income levels) to that in Fragile and conflict affected situations?
Your answer should be compact. 0.55. What is the ratio of the Aid flow from UN agencies (US$) of 1969 in East Asia (all income levels) to that in Heavily indebted poor countries?
Ensure brevity in your answer.  0.58. What is the ratio of the Aid flow from UN agencies (US$) in 1970 in East Asia (all income levels) to that in Heavily indebted poor countries?
Your answer should be compact. 0.53. What is the ratio of the Aid flow from UN agencies (US$) of 1971 in East Asia (all income levels) to that in Heavily indebted poor countries?
Provide a succinct answer. 0.51. What is the ratio of the Aid flow from UN agencies (US$) of 1972 in East Asia (all income levels) to that in Heavily indebted poor countries?
Make the answer very short. 0.81. What is the ratio of the Aid flow from UN agencies (US$) of 1969 in East Asia (developing only) to that in Europe(all income levels)?
Ensure brevity in your answer.  0.12. What is the ratio of the Aid flow from UN agencies (US$) in 1970 in East Asia (developing only) to that in Europe(all income levels)?
Make the answer very short. 0.15. What is the ratio of the Aid flow from UN agencies (US$) of 1971 in East Asia (developing only) to that in Europe(all income levels)?
Provide a short and direct response. 0.17. What is the ratio of the Aid flow from UN agencies (US$) in 1972 in East Asia (developing only) to that in Europe(all income levels)?
Your answer should be very brief. 0.66. What is the ratio of the Aid flow from UN agencies (US$) of 1969 in East Asia (developing only) to that in Europe(developing only)?
Give a very brief answer. 0.13. What is the ratio of the Aid flow from UN agencies (US$) of 1970 in East Asia (developing only) to that in Europe(developing only)?
Provide a succinct answer. 0.17. What is the ratio of the Aid flow from UN agencies (US$) of 1971 in East Asia (developing only) to that in Europe(developing only)?
Your response must be concise. 0.2. What is the ratio of the Aid flow from UN agencies (US$) in 1972 in East Asia (developing only) to that in Europe(developing only)?
Your response must be concise. 0.82. What is the ratio of the Aid flow from UN agencies (US$) in 1969 in East Asia (developing only) to that in Fragile and conflict affected situations?
Provide a short and direct response. 0.12. What is the ratio of the Aid flow from UN agencies (US$) in 1970 in East Asia (developing only) to that in Fragile and conflict affected situations?
Your answer should be very brief. 0.05. What is the ratio of the Aid flow from UN agencies (US$) of 1971 in East Asia (developing only) to that in Fragile and conflict affected situations?
Keep it short and to the point. 0.14. What is the ratio of the Aid flow from UN agencies (US$) in 1972 in East Asia (developing only) to that in Fragile and conflict affected situations?
Keep it short and to the point. 0.11. What is the ratio of the Aid flow from UN agencies (US$) of 1969 in East Asia (developing only) to that in Heavily indebted poor countries?
Keep it short and to the point. 0.12. What is the ratio of the Aid flow from UN agencies (US$) in 1970 in East Asia (developing only) to that in Heavily indebted poor countries?
Ensure brevity in your answer.  0.09. What is the ratio of the Aid flow from UN agencies (US$) in 1971 in East Asia (developing only) to that in Heavily indebted poor countries?
Offer a very short reply. 0.16. What is the ratio of the Aid flow from UN agencies (US$) of 1972 in East Asia (developing only) to that in Heavily indebted poor countries?
Offer a terse response. 0.16. What is the ratio of the Aid flow from UN agencies (US$) in 1969 in Europe(all income levels) to that in Europe(developing only)?
Provide a short and direct response. 1.14. What is the ratio of the Aid flow from UN agencies (US$) in 1970 in Europe(all income levels) to that in Europe(developing only)?
Your response must be concise. 1.16. What is the ratio of the Aid flow from UN agencies (US$) in 1971 in Europe(all income levels) to that in Europe(developing only)?
Your answer should be very brief. 1.14. What is the ratio of the Aid flow from UN agencies (US$) in 1972 in Europe(all income levels) to that in Europe(developing only)?
Ensure brevity in your answer.  1.24. What is the ratio of the Aid flow from UN agencies (US$) of 1969 in Europe(all income levels) to that in Fragile and conflict affected situations?
Keep it short and to the point. 1. What is the ratio of the Aid flow from UN agencies (US$) of 1970 in Europe(all income levels) to that in Fragile and conflict affected situations?
Your response must be concise. 0.31. What is the ratio of the Aid flow from UN agencies (US$) in 1971 in Europe(all income levels) to that in Fragile and conflict affected situations?
Provide a short and direct response. 0.78. What is the ratio of the Aid flow from UN agencies (US$) of 1969 in Europe(all income levels) to that in Heavily indebted poor countries?
Give a very brief answer. 1.05. What is the ratio of the Aid flow from UN agencies (US$) in 1970 in Europe(all income levels) to that in Heavily indebted poor countries?
Your response must be concise. 0.64. What is the ratio of the Aid flow from UN agencies (US$) in 1971 in Europe(all income levels) to that in Heavily indebted poor countries?
Make the answer very short. 0.93. What is the ratio of the Aid flow from UN agencies (US$) of 1972 in Europe(all income levels) to that in Heavily indebted poor countries?
Provide a succinct answer. 0.25. What is the ratio of the Aid flow from UN agencies (US$) of 1969 in Europe(developing only) to that in Fragile and conflict affected situations?
Your response must be concise. 0.88. What is the ratio of the Aid flow from UN agencies (US$) of 1970 in Europe(developing only) to that in Fragile and conflict affected situations?
Your response must be concise. 0.26. What is the ratio of the Aid flow from UN agencies (US$) in 1971 in Europe(developing only) to that in Fragile and conflict affected situations?
Offer a terse response. 0.68. What is the ratio of the Aid flow from UN agencies (US$) in 1972 in Europe(developing only) to that in Fragile and conflict affected situations?
Your answer should be compact. 0.13. What is the ratio of the Aid flow from UN agencies (US$) of 1969 in Europe(developing only) to that in Heavily indebted poor countries?
Keep it short and to the point. 0.93. What is the ratio of the Aid flow from UN agencies (US$) in 1970 in Europe(developing only) to that in Heavily indebted poor countries?
Provide a succinct answer. 0.55. What is the ratio of the Aid flow from UN agencies (US$) of 1971 in Europe(developing only) to that in Heavily indebted poor countries?
Offer a terse response. 0.82. What is the ratio of the Aid flow from UN agencies (US$) in 1972 in Europe(developing only) to that in Heavily indebted poor countries?
Give a very brief answer. 0.2. What is the ratio of the Aid flow from UN agencies (US$) in 1969 in Fragile and conflict affected situations to that in Heavily indebted poor countries?
Offer a very short reply. 1.05. What is the ratio of the Aid flow from UN agencies (US$) of 1970 in Fragile and conflict affected situations to that in Heavily indebted poor countries?
Your response must be concise. 2.08. What is the ratio of the Aid flow from UN agencies (US$) of 1971 in Fragile and conflict affected situations to that in Heavily indebted poor countries?
Offer a very short reply. 1.2. What is the ratio of the Aid flow from UN agencies (US$) in 1972 in Fragile and conflict affected situations to that in Heavily indebted poor countries?
Offer a terse response. 1.48. What is the difference between the highest and the second highest Aid flow from UN agencies (US$) of 1970?
Keep it short and to the point. 1.16e+07. What is the difference between the highest and the second highest Aid flow from UN agencies (US$) in 1971?
Ensure brevity in your answer.  4.02e+06. What is the difference between the highest and the second highest Aid flow from UN agencies (US$) in 1972?
Give a very brief answer. 7.86e+06. What is the difference between the highest and the lowest Aid flow from UN agencies (US$) of 1969?
Ensure brevity in your answer.  9.69e+06. What is the difference between the highest and the lowest Aid flow from UN agencies (US$) of 1970?
Ensure brevity in your answer.  2.12e+07. What is the difference between the highest and the lowest Aid flow from UN agencies (US$) of 1971?
Offer a very short reply. 2.12e+07. What is the difference between the highest and the lowest Aid flow from UN agencies (US$) in 1972?
Ensure brevity in your answer.  2.15e+07. 